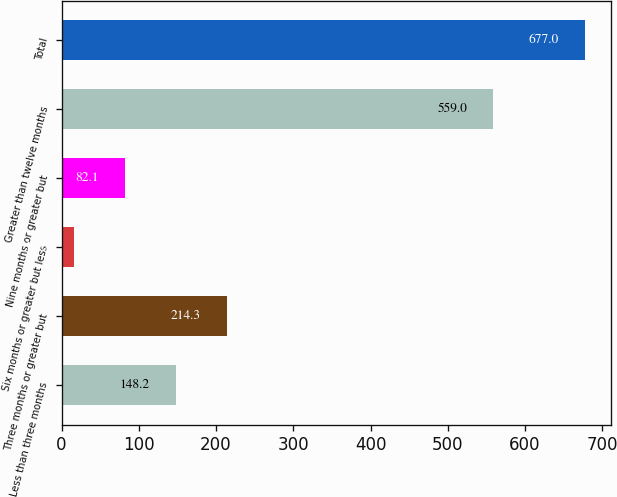<chart> <loc_0><loc_0><loc_500><loc_500><bar_chart><fcel>Less than three months<fcel>Three months or greater but<fcel>Six months or greater but less<fcel>Nine months or greater but<fcel>Greater than twelve months<fcel>Total<nl><fcel>148.2<fcel>214.3<fcel>16<fcel>82.1<fcel>559<fcel>677<nl></chart> 